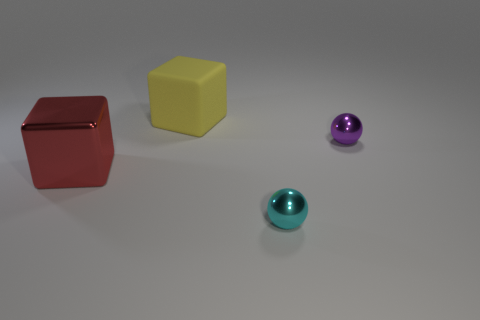Can you describe the colors of the objects? Certainly! The objects include a red cube with a glossy finish, a yellow cube with a matte finish, and two spheres, one purple and one teal, both with reflective surfaces. 